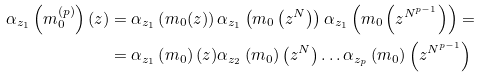Convert formula to latex. <formula><loc_0><loc_0><loc_500><loc_500>\alpha _ { z _ { 1 } } \left ( m _ { 0 } ^ { ( p ) } \right ) ( z ) & = \alpha _ { z _ { 1 } } \left ( m _ { 0 } ( z ) \right ) \alpha _ { z _ { 1 } } \left ( m _ { 0 } \left ( z ^ { N } \right ) \right ) \alpha _ { z _ { 1 } } \left ( m _ { 0 } \left ( z ^ { N ^ { p - 1 } } \right ) \right ) = \\ & = \alpha _ { z _ { 1 } } \left ( m _ { 0 } \right ) ( z ) \alpha _ { z _ { 2 } } \left ( m _ { 0 } \right ) \left ( z ^ { N } \right ) \dots \alpha _ { z _ { p } } \left ( m _ { 0 } \right ) \left ( z ^ { N ^ { p - 1 } } \right )</formula> 